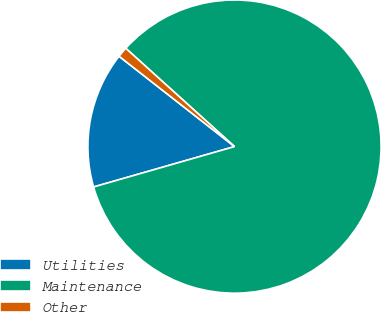Convert chart to OTSL. <chart><loc_0><loc_0><loc_500><loc_500><pie_chart><fcel>Utilities<fcel>Maintenance<fcel>Other<nl><fcel>15.01%<fcel>83.86%<fcel>1.13%<nl></chart> 